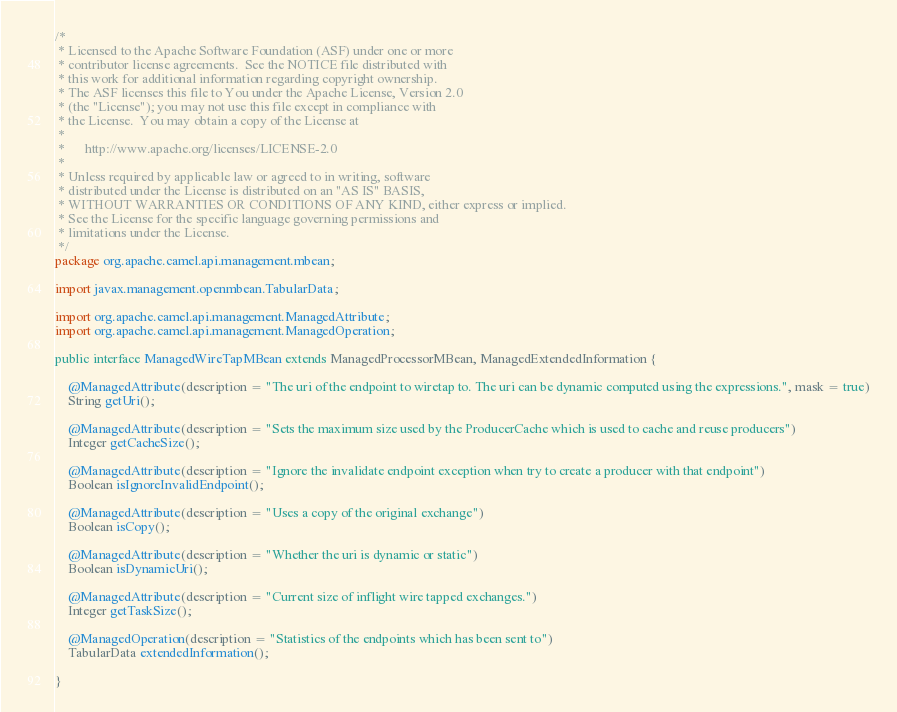<code> <loc_0><loc_0><loc_500><loc_500><_Java_>/*
 * Licensed to the Apache Software Foundation (ASF) under one or more
 * contributor license agreements.  See the NOTICE file distributed with
 * this work for additional information regarding copyright ownership.
 * The ASF licenses this file to You under the Apache License, Version 2.0
 * (the "License"); you may not use this file except in compliance with
 * the License.  You may obtain a copy of the License at
 *
 *      http://www.apache.org/licenses/LICENSE-2.0
 *
 * Unless required by applicable law or agreed to in writing, software
 * distributed under the License is distributed on an "AS IS" BASIS,
 * WITHOUT WARRANTIES OR CONDITIONS OF ANY KIND, either express or implied.
 * See the License for the specific language governing permissions and
 * limitations under the License.
 */
package org.apache.camel.api.management.mbean;

import javax.management.openmbean.TabularData;

import org.apache.camel.api.management.ManagedAttribute;
import org.apache.camel.api.management.ManagedOperation;

public interface ManagedWireTapMBean extends ManagedProcessorMBean, ManagedExtendedInformation {

    @ManagedAttribute(description = "The uri of the endpoint to wiretap to. The uri can be dynamic computed using the expressions.", mask = true)
    String getUri();

    @ManagedAttribute(description = "Sets the maximum size used by the ProducerCache which is used to cache and reuse producers")
    Integer getCacheSize();

    @ManagedAttribute(description = "Ignore the invalidate endpoint exception when try to create a producer with that endpoint")
    Boolean isIgnoreInvalidEndpoint();

    @ManagedAttribute(description = "Uses a copy of the original exchange")
    Boolean isCopy();

    @ManagedAttribute(description = "Whether the uri is dynamic or static")
    Boolean isDynamicUri();

    @ManagedAttribute(description = "Current size of inflight wire tapped exchanges.")
    Integer getTaskSize();

    @ManagedOperation(description = "Statistics of the endpoints which has been sent to")
    TabularData extendedInformation();

}</code> 